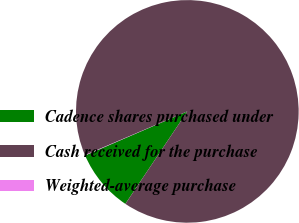Convert chart. <chart><loc_0><loc_0><loc_500><loc_500><pie_chart><fcel>Cadence shares purchased under<fcel>Cash received for the purchase<fcel>Weighted-average purchase<nl><fcel>9.13%<fcel>90.82%<fcel>0.05%<nl></chart> 